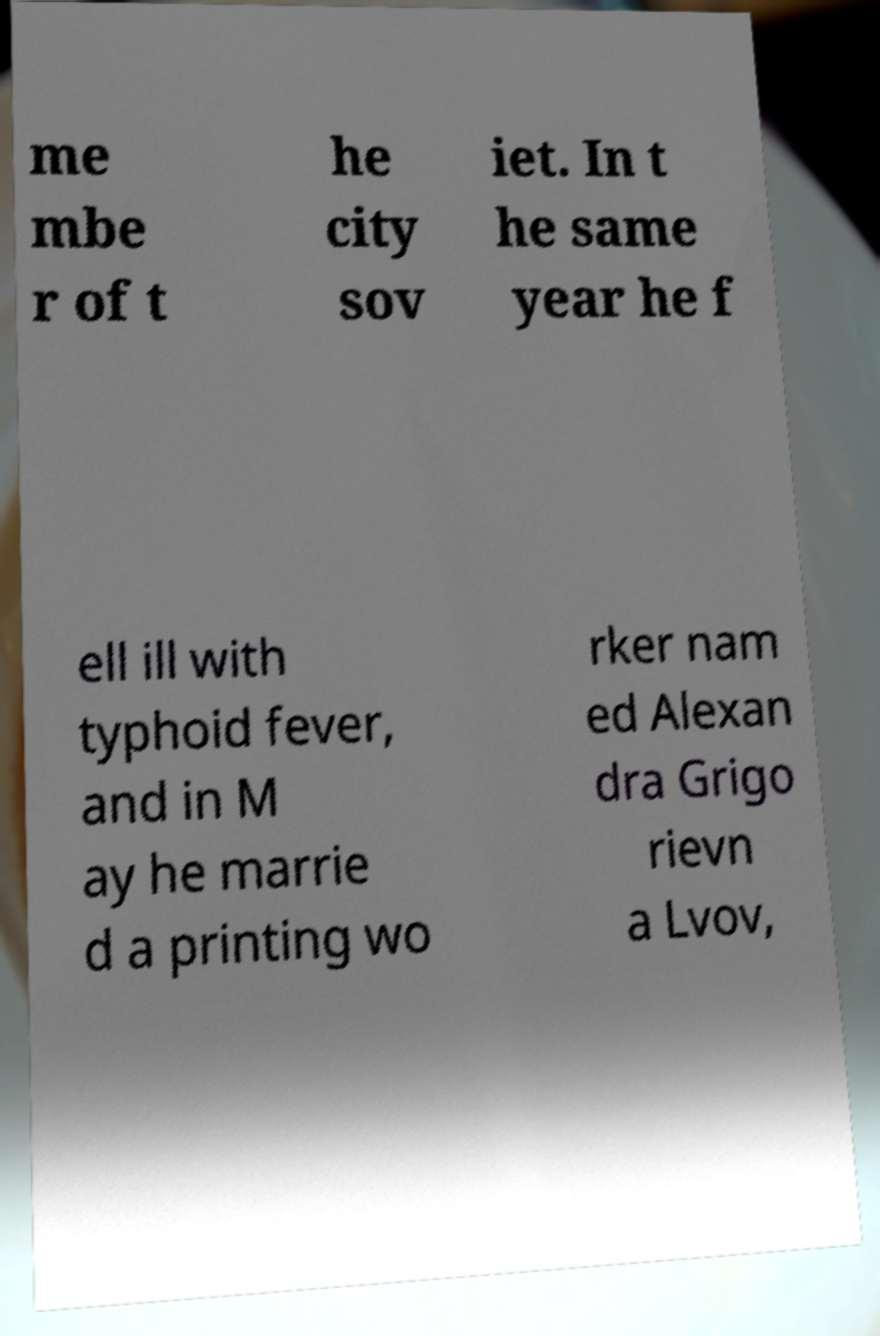Can you accurately transcribe the text from the provided image for me? me mbe r of t he city sov iet. In t he same year he f ell ill with typhoid fever, and in M ay he marrie d a printing wo rker nam ed Alexan dra Grigo rievn a Lvov, 